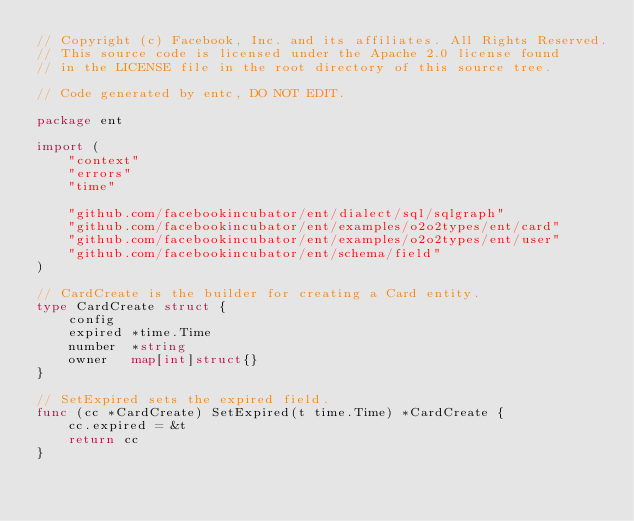Convert code to text. <code><loc_0><loc_0><loc_500><loc_500><_Go_>// Copyright (c) Facebook, Inc. and its affiliates. All Rights Reserved.
// This source code is licensed under the Apache 2.0 license found
// in the LICENSE file in the root directory of this source tree.

// Code generated by entc, DO NOT EDIT.

package ent

import (
	"context"
	"errors"
	"time"

	"github.com/facebookincubator/ent/dialect/sql/sqlgraph"
	"github.com/facebookincubator/ent/examples/o2o2types/ent/card"
	"github.com/facebookincubator/ent/examples/o2o2types/ent/user"
	"github.com/facebookincubator/ent/schema/field"
)

// CardCreate is the builder for creating a Card entity.
type CardCreate struct {
	config
	expired *time.Time
	number  *string
	owner   map[int]struct{}
}

// SetExpired sets the expired field.
func (cc *CardCreate) SetExpired(t time.Time) *CardCreate {
	cc.expired = &t
	return cc
}
</code> 